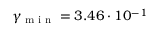<formula> <loc_0><loc_0><loc_500><loc_500>\gamma _ { \min } = 3 . 4 6 \cdot 1 0 ^ { - 1 }</formula> 